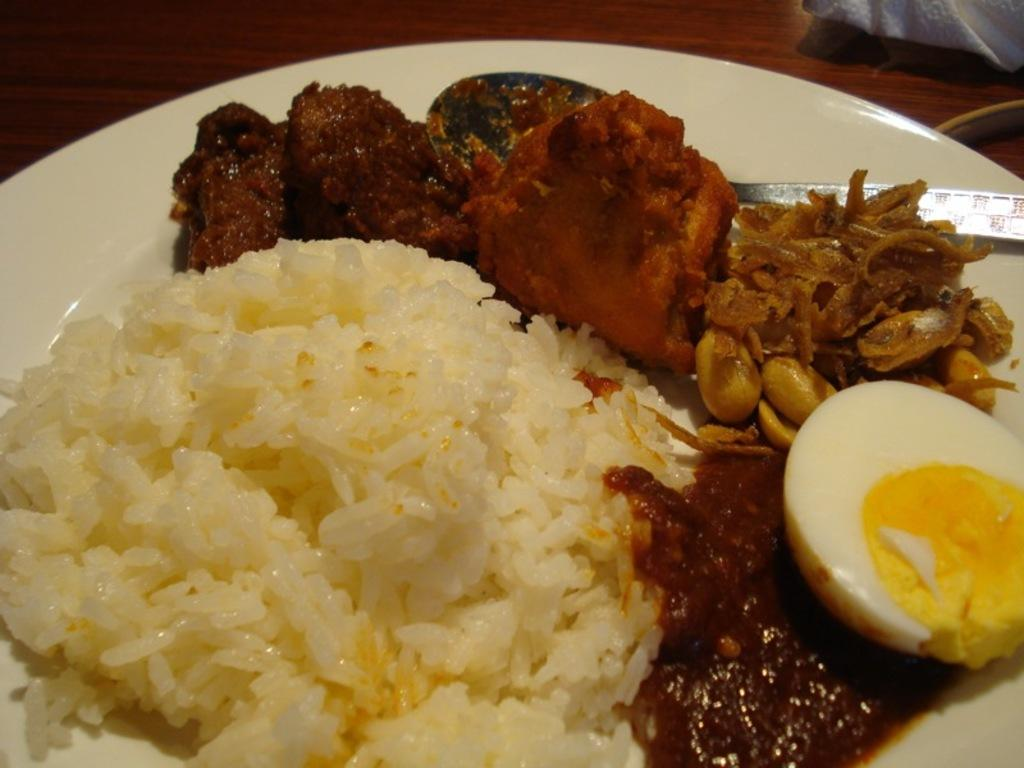What type of food is on the plate in the image? There is rice, a half-boiled egg, and cooked curries on the plate. Can you describe the egg on the plate? The egg on the plate is half-boiled. What other types of food are on the plate besides rice? There are cooked curries on the plate. How does the beginner learn to cook the rice in the image? The image does not show anyone learning to cook or provide any information about cooking, so it cannot be determined from the image. 